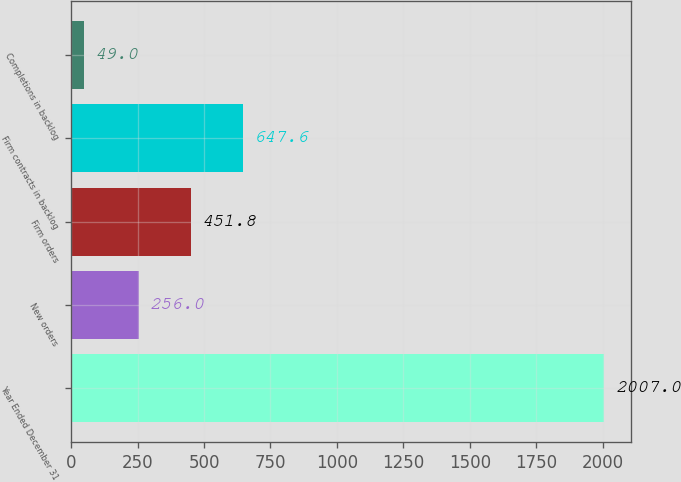Convert chart to OTSL. <chart><loc_0><loc_0><loc_500><loc_500><bar_chart><fcel>Year Ended December 31<fcel>New orders<fcel>Firm orders<fcel>Firm contracts in backlog<fcel>Completions in backlog<nl><fcel>2007<fcel>256<fcel>451.8<fcel>647.6<fcel>49<nl></chart> 